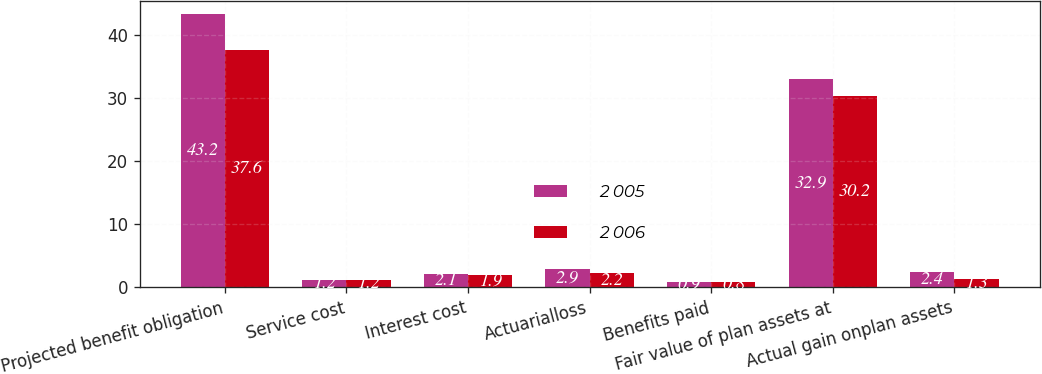Convert chart. <chart><loc_0><loc_0><loc_500><loc_500><stacked_bar_chart><ecel><fcel>Projected benefit obligation<fcel>Service cost<fcel>Interest cost<fcel>Actuarialloss<fcel>Benefits paid<fcel>Fair value of plan assets at<fcel>Actual gain onplan assets<nl><fcel>2 005<fcel>43.2<fcel>1.2<fcel>2.1<fcel>2.9<fcel>0.9<fcel>32.9<fcel>2.4<nl><fcel>2 006<fcel>37.6<fcel>1.2<fcel>1.9<fcel>2.2<fcel>0.8<fcel>30.2<fcel>1.3<nl></chart> 